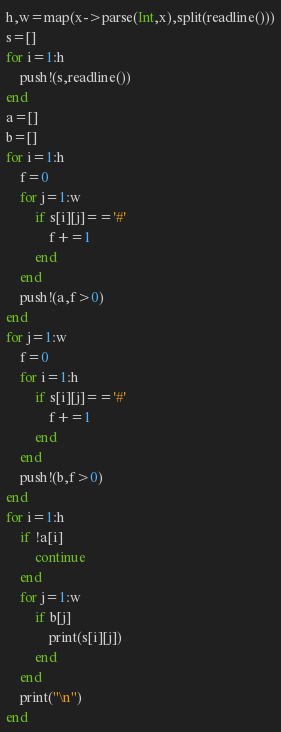Convert code to text. <code><loc_0><loc_0><loc_500><loc_500><_Julia_>h,w=map(x->parse(Int,x),split(readline()))
s=[]
for i=1:h
	push!(s,readline())
end
a=[]
b=[]
for i=1:h
	f=0
	for j=1:w
		if s[i][j]=='#'
			f+=1
		end
	end
	push!(a,f>0)
end
for j=1:w
	f=0
	for i=1:h
		if s[i][j]=='#'
			f+=1
		end
	end
	push!(b,f>0)
end
for i=1:h
	if !a[i]
		continue
	end
	for j=1:w
		if b[j]
			print(s[i][j])
		end
	end
	print("\n")
end
</code> 